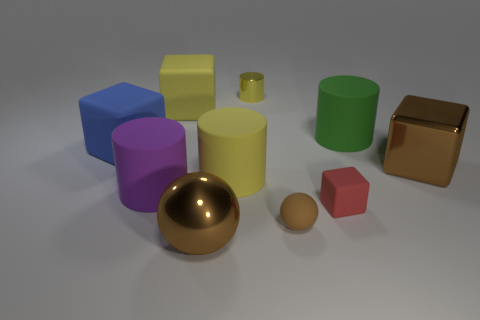Subtract 1 cylinders. How many cylinders are left? 3 Subtract all green blocks. Subtract all brown balls. How many blocks are left? 4 Subtract all cubes. How many objects are left? 6 Subtract all big green rubber cylinders. Subtract all large yellow metallic objects. How many objects are left? 9 Add 7 big cubes. How many big cubes are left? 10 Add 1 big green cylinders. How many big green cylinders exist? 2 Subtract 0 red spheres. How many objects are left? 10 